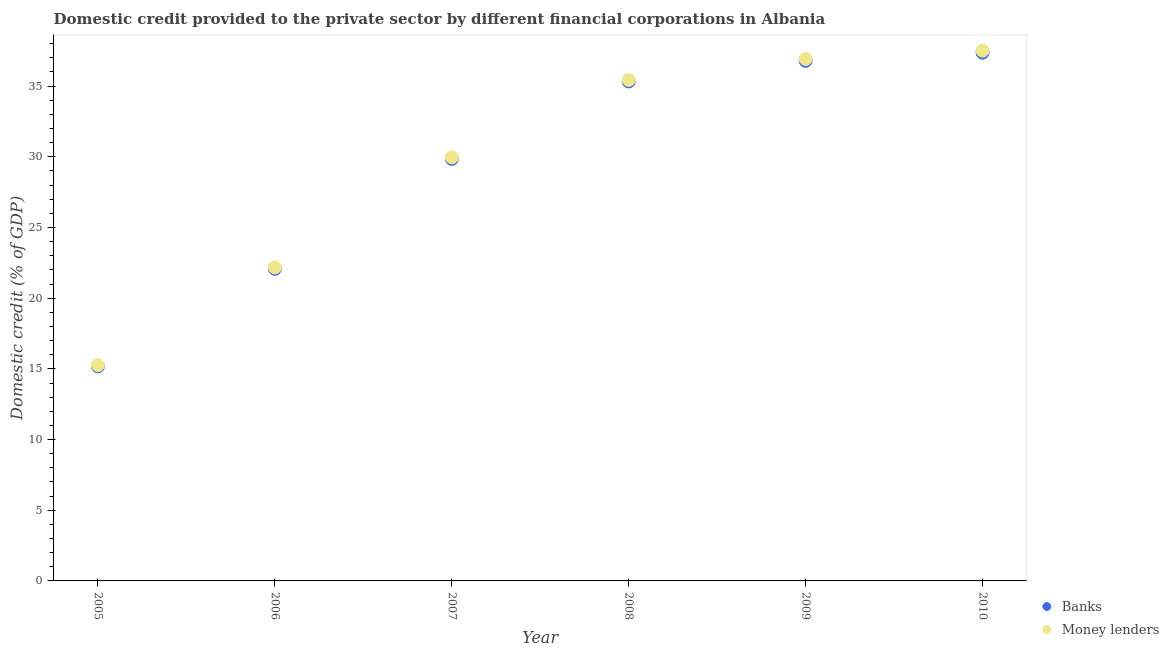Is the number of dotlines equal to the number of legend labels?
Your response must be concise. Yes. What is the domestic credit provided by money lenders in 2009?
Ensure brevity in your answer.  36.92. Across all years, what is the maximum domestic credit provided by banks?
Offer a terse response. 37.37. Across all years, what is the minimum domestic credit provided by banks?
Give a very brief answer. 15.18. What is the total domestic credit provided by money lenders in the graph?
Your response must be concise. 177.27. What is the difference between the domestic credit provided by banks in 2006 and that in 2009?
Offer a very short reply. -14.71. What is the difference between the domestic credit provided by banks in 2006 and the domestic credit provided by money lenders in 2008?
Offer a very short reply. -13.37. What is the average domestic credit provided by banks per year?
Your response must be concise. 29.43. In the year 2010, what is the difference between the domestic credit provided by banks and domestic credit provided by money lenders?
Provide a succinct answer. -0.14. In how many years, is the domestic credit provided by banks greater than 30 %?
Offer a terse response. 3. What is the ratio of the domestic credit provided by money lenders in 2008 to that in 2009?
Your answer should be compact. 0.96. Is the domestic credit provided by money lenders in 2005 less than that in 2007?
Offer a very short reply. Yes. Is the difference between the domestic credit provided by banks in 2005 and 2010 greater than the difference between the domestic credit provided by money lenders in 2005 and 2010?
Your answer should be compact. Yes. What is the difference between the highest and the second highest domestic credit provided by money lenders?
Give a very brief answer. 0.59. What is the difference between the highest and the lowest domestic credit provided by money lenders?
Provide a short and direct response. 22.24. How many dotlines are there?
Make the answer very short. 2. Are the values on the major ticks of Y-axis written in scientific E-notation?
Offer a terse response. No. Does the graph contain any zero values?
Offer a very short reply. No. Where does the legend appear in the graph?
Your answer should be compact. Bottom right. How are the legend labels stacked?
Give a very brief answer. Vertical. What is the title of the graph?
Give a very brief answer. Domestic credit provided to the private sector by different financial corporations in Albania. Does "Methane emissions" appear as one of the legend labels in the graph?
Give a very brief answer. No. What is the label or title of the X-axis?
Offer a terse response. Year. What is the label or title of the Y-axis?
Your answer should be compact. Domestic credit (% of GDP). What is the Domestic credit (% of GDP) in Banks in 2005?
Offer a very short reply. 15.18. What is the Domestic credit (% of GDP) in Money lenders in 2005?
Provide a succinct answer. 15.26. What is the Domestic credit (% of GDP) of Banks in 2006?
Make the answer very short. 22.07. What is the Domestic credit (% of GDP) in Money lenders in 2006?
Offer a terse response. 22.17. What is the Domestic credit (% of GDP) of Banks in 2007?
Provide a short and direct response. 29.86. What is the Domestic credit (% of GDP) of Money lenders in 2007?
Provide a succinct answer. 29.96. What is the Domestic credit (% of GDP) in Banks in 2008?
Provide a short and direct response. 35.33. What is the Domestic credit (% of GDP) in Money lenders in 2008?
Your answer should be very brief. 35.44. What is the Domestic credit (% of GDP) of Banks in 2009?
Provide a succinct answer. 36.78. What is the Domestic credit (% of GDP) of Money lenders in 2009?
Make the answer very short. 36.92. What is the Domestic credit (% of GDP) of Banks in 2010?
Provide a succinct answer. 37.37. What is the Domestic credit (% of GDP) in Money lenders in 2010?
Your answer should be very brief. 37.51. Across all years, what is the maximum Domestic credit (% of GDP) in Banks?
Ensure brevity in your answer.  37.37. Across all years, what is the maximum Domestic credit (% of GDP) of Money lenders?
Offer a terse response. 37.51. Across all years, what is the minimum Domestic credit (% of GDP) of Banks?
Give a very brief answer. 15.18. Across all years, what is the minimum Domestic credit (% of GDP) in Money lenders?
Offer a terse response. 15.26. What is the total Domestic credit (% of GDP) of Banks in the graph?
Your answer should be very brief. 176.59. What is the total Domestic credit (% of GDP) of Money lenders in the graph?
Your answer should be compact. 177.27. What is the difference between the Domestic credit (% of GDP) in Banks in 2005 and that in 2006?
Provide a succinct answer. -6.9. What is the difference between the Domestic credit (% of GDP) in Money lenders in 2005 and that in 2006?
Your answer should be very brief. -6.91. What is the difference between the Domestic credit (% of GDP) of Banks in 2005 and that in 2007?
Your answer should be very brief. -14.68. What is the difference between the Domestic credit (% of GDP) of Money lenders in 2005 and that in 2007?
Give a very brief answer. -14.7. What is the difference between the Domestic credit (% of GDP) in Banks in 2005 and that in 2008?
Offer a very short reply. -20.16. What is the difference between the Domestic credit (% of GDP) in Money lenders in 2005 and that in 2008?
Ensure brevity in your answer.  -20.18. What is the difference between the Domestic credit (% of GDP) of Banks in 2005 and that in 2009?
Your answer should be very brief. -21.61. What is the difference between the Domestic credit (% of GDP) of Money lenders in 2005 and that in 2009?
Give a very brief answer. -21.65. What is the difference between the Domestic credit (% of GDP) in Banks in 2005 and that in 2010?
Keep it short and to the point. -22.19. What is the difference between the Domestic credit (% of GDP) in Money lenders in 2005 and that in 2010?
Make the answer very short. -22.24. What is the difference between the Domestic credit (% of GDP) of Banks in 2006 and that in 2007?
Make the answer very short. -7.78. What is the difference between the Domestic credit (% of GDP) of Money lenders in 2006 and that in 2007?
Your response must be concise. -7.79. What is the difference between the Domestic credit (% of GDP) in Banks in 2006 and that in 2008?
Ensure brevity in your answer.  -13.26. What is the difference between the Domestic credit (% of GDP) in Money lenders in 2006 and that in 2008?
Ensure brevity in your answer.  -13.27. What is the difference between the Domestic credit (% of GDP) in Banks in 2006 and that in 2009?
Your answer should be very brief. -14.71. What is the difference between the Domestic credit (% of GDP) of Money lenders in 2006 and that in 2009?
Your answer should be very brief. -14.74. What is the difference between the Domestic credit (% of GDP) of Banks in 2006 and that in 2010?
Ensure brevity in your answer.  -15.29. What is the difference between the Domestic credit (% of GDP) of Money lenders in 2006 and that in 2010?
Ensure brevity in your answer.  -15.34. What is the difference between the Domestic credit (% of GDP) of Banks in 2007 and that in 2008?
Make the answer very short. -5.48. What is the difference between the Domestic credit (% of GDP) in Money lenders in 2007 and that in 2008?
Provide a succinct answer. -5.48. What is the difference between the Domestic credit (% of GDP) of Banks in 2007 and that in 2009?
Offer a very short reply. -6.93. What is the difference between the Domestic credit (% of GDP) of Money lenders in 2007 and that in 2009?
Ensure brevity in your answer.  -6.95. What is the difference between the Domestic credit (% of GDP) in Banks in 2007 and that in 2010?
Your answer should be very brief. -7.51. What is the difference between the Domestic credit (% of GDP) of Money lenders in 2007 and that in 2010?
Provide a succinct answer. -7.54. What is the difference between the Domestic credit (% of GDP) of Banks in 2008 and that in 2009?
Make the answer very short. -1.45. What is the difference between the Domestic credit (% of GDP) of Money lenders in 2008 and that in 2009?
Provide a short and direct response. -1.48. What is the difference between the Domestic credit (% of GDP) in Banks in 2008 and that in 2010?
Offer a very short reply. -2.03. What is the difference between the Domestic credit (% of GDP) in Money lenders in 2008 and that in 2010?
Your response must be concise. -2.07. What is the difference between the Domestic credit (% of GDP) of Banks in 2009 and that in 2010?
Your answer should be compact. -0.58. What is the difference between the Domestic credit (% of GDP) of Money lenders in 2009 and that in 2010?
Your response must be concise. -0.59. What is the difference between the Domestic credit (% of GDP) of Banks in 2005 and the Domestic credit (% of GDP) of Money lenders in 2006?
Provide a short and direct response. -7. What is the difference between the Domestic credit (% of GDP) in Banks in 2005 and the Domestic credit (% of GDP) in Money lenders in 2007?
Offer a terse response. -14.79. What is the difference between the Domestic credit (% of GDP) in Banks in 2005 and the Domestic credit (% of GDP) in Money lenders in 2008?
Provide a succinct answer. -20.26. What is the difference between the Domestic credit (% of GDP) of Banks in 2005 and the Domestic credit (% of GDP) of Money lenders in 2009?
Ensure brevity in your answer.  -21.74. What is the difference between the Domestic credit (% of GDP) in Banks in 2005 and the Domestic credit (% of GDP) in Money lenders in 2010?
Provide a short and direct response. -22.33. What is the difference between the Domestic credit (% of GDP) of Banks in 2006 and the Domestic credit (% of GDP) of Money lenders in 2007?
Keep it short and to the point. -7.89. What is the difference between the Domestic credit (% of GDP) in Banks in 2006 and the Domestic credit (% of GDP) in Money lenders in 2008?
Offer a very short reply. -13.37. What is the difference between the Domestic credit (% of GDP) of Banks in 2006 and the Domestic credit (% of GDP) of Money lenders in 2009?
Ensure brevity in your answer.  -14.84. What is the difference between the Domestic credit (% of GDP) in Banks in 2006 and the Domestic credit (% of GDP) in Money lenders in 2010?
Give a very brief answer. -15.43. What is the difference between the Domestic credit (% of GDP) in Banks in 2007 and the Domestic credit (% of GDP) in Money lenders in 2008?
Your answer should be compact. -5.58. What is the difference between the Domestic credit (% of GDP) in Banks in 2007 and the Domestic credit (% of GDP) in Money lenders in 2009?
Keep it short and to the point. -7.06. What is the difference between the Domestic credit (% of GDP) of Banks in 2007 and the Domestic credit (% of GDP) of Money lenders in 2010?
Offer a terse response. -7.65. What is the difference between the Domestic credit (% of GDP) of Banks in 2008 and the Domestic credit (% of GDP) of Money lenders in 2009?
Your answer should be compact. -1.59. What is the difference between the Domestic credit (% of GDP) in Banks in 2008 and the Domestic credit (% of GDP) in Money lenders in 2010?
Offer a very short reply. -2.18. What is the difference between the Domestic credit (% of GDP) in Banks in 2009 and the Domestic credit (% of GDP) in Money lenders in 2010?
Your response must be concise. -0.72. What is the average Domestic credit (% of GDP) of Banks per year?
Keep it short and to the point. 29.43. What is the average Domestic credit (% of GDP) of Money lenders per year?
Your answer should be very brief. 29.54. In the year 2005, what is the difference between the Domestic credit (% of GDP) of Banks and Domestic credit (% of GDP) of Money lenders?
Provide a short and direct response. -0.09. In the year 2006, what is the difference between the Domestic credit (% of GDP) in Banks and Domestic credit (% of GDP) in Money lenders?
Keep it short and to the point. -0.1. In the year 2007, what is the difference between the Domestic credit (% of GDP) in Banks and Domestic credit (% of GDP) in Money lenders?
Your answer should be compact. -0.11. In the year 2008, what is the difference between the Domestic credit (% of GDP) of Banks and Domestic credit (% of GDP) of Money lenders?
Offer a very short reply. -0.11. In the year 2009, what is the difference between the Domestic credit (% of GDP) in Banks and Domestic credit (% of GDP) in Money lenders?
Your answer should be compact. -0.13. In the year 2010, what is the difference between the Domestic credit (% of GDP) in Banks and Domestic credit (% of GDP) in Money lenders?
Your answer should be compact. -0.14. What is the ratio of the Domestic credit (% of GDP) of Banks in 2005 to that in 2006?
Your response must be concise. 0.69. What is the ratio of the Domestic credit (% of GDP) of Money lenders in 2005 to that in 2006?
Your answer should be compact. 0.69. What is the ratio of the Domestic credit (% of GDP) in Banks in 2005 to that in 2007?
Your answer should be very brief. 0.51. What is the ratio of the Domestic credit (% of GDP) of Money lenders in 2005 to that in 2007?
Make the answer very short. 0.51. What is the ratio of the Domestic credit (% of GDP) of Banks in 2005 to that in 2008?
Make the answer very short. 0.43. What is the ratio of the Domestic credit (% of GDP) of Money lenders in 2005 to that in 2008?
Ensure brevity in your answer.  0.43. What is the ratio of the Domestic credit (% of GDP) of Banks in 2005 to that in 2009?
Keep it short and to the point. 0.41. What is the ratio of the Domestic credit (% of GDP) in Money lenders in 2005 to that in 2009?
Make the answer very short. 0.41. What is the ratio of the Domestic credit (% of GDP) of Banks in 2005 to that in 2010?
Your answer should be very brief. 0.41. What is the ratio of the Domestic credit (% of GDP) of Money lenders in 2005 to that in 2010?
Ensure brevity in your answer.  0.41. What is the ratio of the Domestic credit (% of GDP) in Banks in 2006 to that in 2007?
Offer a terse response. 0.74. What is the ratio of the Domestic credit (% of GDP) of Money lenders in 2006 to that in 2007?
Your answer should be compact. 0.74. What is the ratio of the Domestic credit (% of GDP) of Banks in 2006 to that in 2008?
Provide a short and direct response. 0.62. What is the ratio of the Domestic credit (% of GDP) in Money lenders in 2006 to that in 2008?
Ensure brevity in your answer.  0.63. What is the ratio of the Domestic credit (% of GDP) of Banks in 2006 to that in 2009?
Your response must be concise. 0.6. What is the ratio of the Domestic credit (% of GDP) of Money lenders in 2006 to that in 2009?
Provide a succinct answer. 0.6. What is the ratio of the Domestic credit (% of GDP) in Banks in 2006 to that in 2010?
Provide a succinct answer. 0.59. What is the ratio of the Domestic credit (% of GDP) in Money lenders in 2006 to that in 2010?
Keep it short and to the point. 0.59. What is the ratio of the Domestic credit (% of GDP) of Banks in 2007 to that in 2008?
Offer a very short reply. 0.84. What is the ratio of the Domestic credit (% of GDP) in Money lenders in 2007 to that in 2008?
Provide a succinct answer. 0.85. What is the ratio of the Domestic credit (% of GDP) of Banks in 2007 to that in 2009?
Provide a short and direct response. 0.81. What is the ratio of the Domestic credit (% of GDP) in Money lenders in 2007 to that in 2009?
Your answer should be compact. 0.81. What is the ratio of the Domestic credit (% of GDP) in Banks in 2007 to that in 2010?
Offer a terse response. 0.8. What is the ratio of the Domestic credit (% of GDP) of Money lenders in 2007 to that in 2010?
Ensure brevity in your answer.  0.8. What is the ratio of the Domestic credit (% of GDP) of Banks in 2008 to that in 2009?
Give a very brief answer. 0.96. What is the ratio of the Domestic credit (% of GDP) in Banks in 2008 to that in 2010?
Make the answer very short. 0.95. What is the ratio of the Domestic credit (% of GDP) of Money lenders in 2008 to that in 2010?
Give a very brief answer. 0.94. What is the ratio of the Domestic credit (% of GDP) in Banks in 2009 to that in 2010?
Your response must be concise. 0.98. What is the ratio of the Domestic credit (% of GDP) in Money lenders in 2009 to that in 2010?
Keep it short and to the point. 0.98. What is the difference between the highest and the second highest Domestic credit (% of GDP) of Banks?
Offer a terse response. 0.58. What is the difference between the highest and the second highest Domestic credit (% of GDP) of Money lenders?
Keep it short and to the point. 0.59. What is the difference between the highest and the lowest Domestic credit (% of GDP) of Banks?
Ensure brevity in your answer.  22.19. What is the difference between the highest and the lowest Domestic credit (% of GDP) of Money lenders?
Your answer should be very brief. 22.24. 